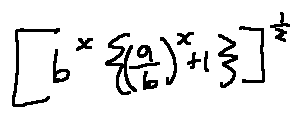<formula> <loc_0><loc_0><loc_500><loc_500>[ b ^ { x } \{ ( \frac { a } { b } ) ^ { x } + 1 \} ] ^ { \frac { 1 } { x } }</formula> 